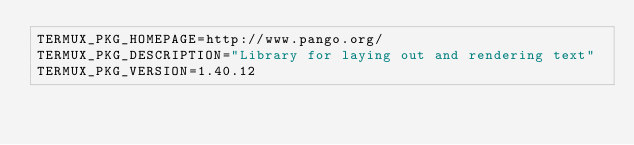Convert code to text. <code><loc_0><loc_0><loc_500><loc_500><_Bash_>TERMUX_PKG_HOMEPAGE=http://www.pango.org/
TERMUX_PKG_DESCRIPTION="Library for laying out and rendering text"
TERMUX_PKG_VERSION=1.40.12</code> 